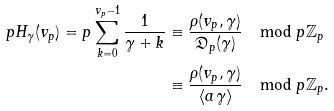Convert formula to latex. <formula><loc_0><loc_0><loc_500><loc_500>p H _ { \gamma } ( v _ { p } ) = p \sum _ { k = 0 } ^ { v _ { p } - 1 } \frac { 1 } { \gamma + k } & \equiv \frac { \rho ( v _ { p } , \gamma ) } { \mathfrak { D } _ { p } ( \gamma ) } \mod p \mathbb { Z } _ { p } \\ & \equiv \frac { \rho ( v _ { p } , \gamma ) } { \langle a \gamma \rangle } \mod p \mathbb { Z } _ { p } .</formula> 